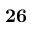Convert formula to latex. <formula><loc_0><loc_0><loc_500><loc_500>2 6</formula> 